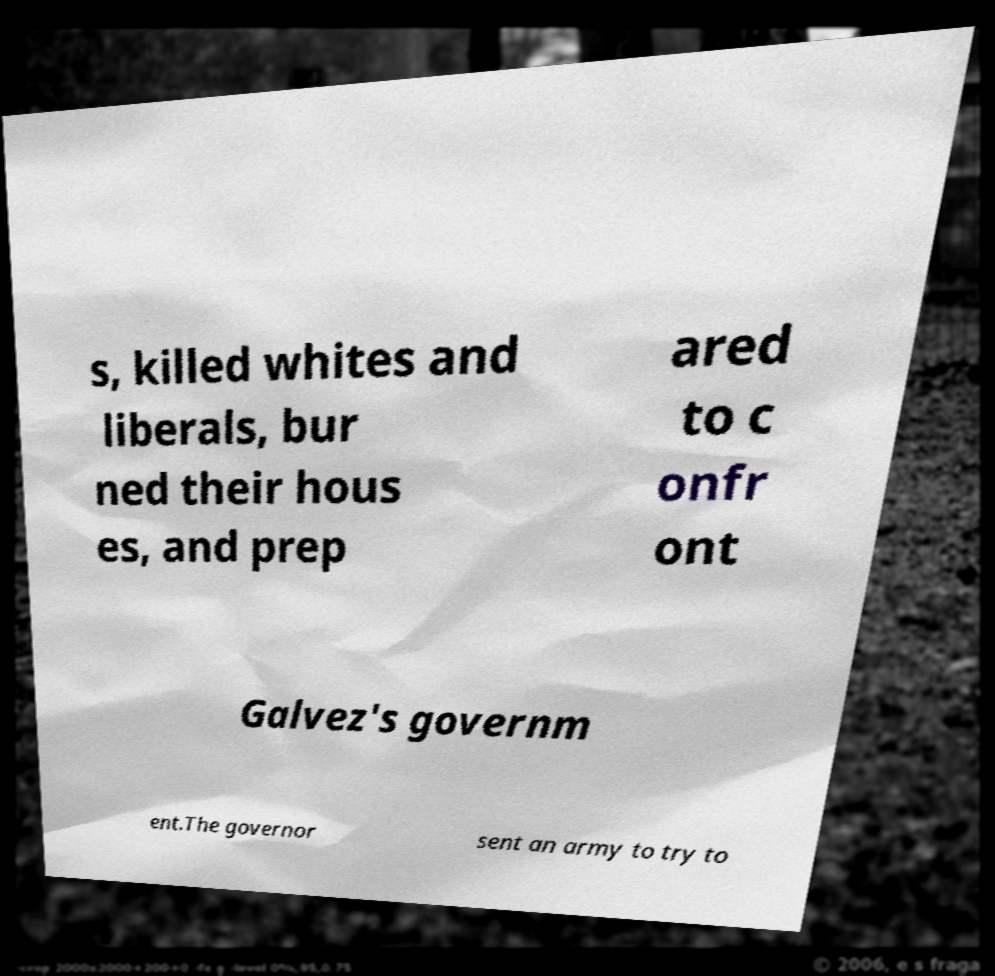For documentation purposes, I need the text within this image transcribed. Could you provide that? s, killed whites and liberals, bur ned their hous es, and prep ared to c onfr ont Galvez's governm ent.The governor sent an army to try to 